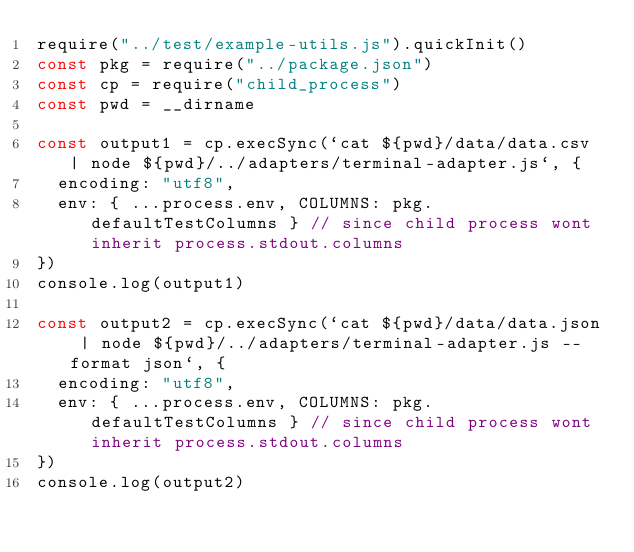<code> <loc_0><loc_0><loc_500><loc_500><_JavaScript_>require("../test/example-utils.js").quickInit()
const pkg = require("../package.json")
const cp = require("child_process")
const pwd = __dirname

const output1 = cp.execSync(`cat ${pwd}/data/data.csv | node ${pwd}/../adapters/terminal-adapter.js`, {
  encoding: "utf8",
  env: { ...process.env, COLUMNS: pkg.defaultTestColumns } // since child process wont inherit process.stdout.columns
})
console.log(output1)

const output2 = cp.execSync(`cat ${pwd}/data/data.json | node ${pwd}/../adapters/terminal-adapter.js --format json`, {
  encoding: "utf8",
  env: { ...process.env, COLUMNS: pkg.defaultTestColumns } // since child process wont inherit process.stdout.columns
})
console.log(output2)
</code> 